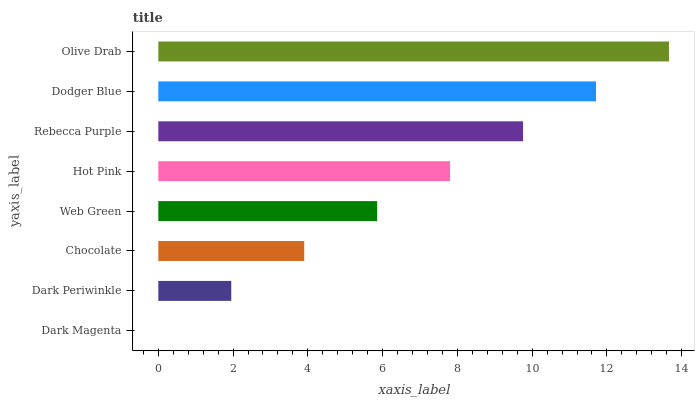Is Dark Magenta the minimum?
Answer yes or no. Yes. Is Olive Drab the maximum?
Answer yes or no. Yes. Is Dark Periwinkle the minimum?
Answer yes or no. No. Is Dark Periwinkle the maximum?
Answer yes or no. No. Is Dark Periwinkle greater than Dark Magenta?
Answer yes or no. Yes. Is Dark Magenta less than Dark Periwinkle?
Answer yes or no. Yes. Is Dark Magenta greater than Dark Periwinkle?
Answer yes or no. No. Is Dark Periwinkle less than Dark Magenta?
Answer yes or no. No. Is Hot Pink the high median?
Answer yes or no. Yes. Is Web Green the low median?
Answer yes or no. Yes. Is Chocolate the high median?
Answer yes or no. No. Is Olive Drab the low median?
Answer yes or no. No. 